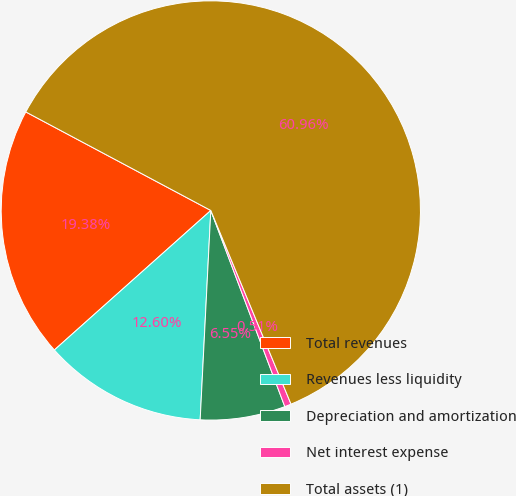Convert chart to OTSL. <chart><loc_0><loc_0><loc_500><loc_500><pie_chart><fcel>Total revenues<fcel>Revenues less liquidity<fcel>Depreciation and amortization<fcel>Net interest expense<fcel>Total assets (1)<nl><fcel>19.38%<fcel>12.6%<fcel>6.55%<fcel>0.51%<fcel>60.96%<nl></chart> 